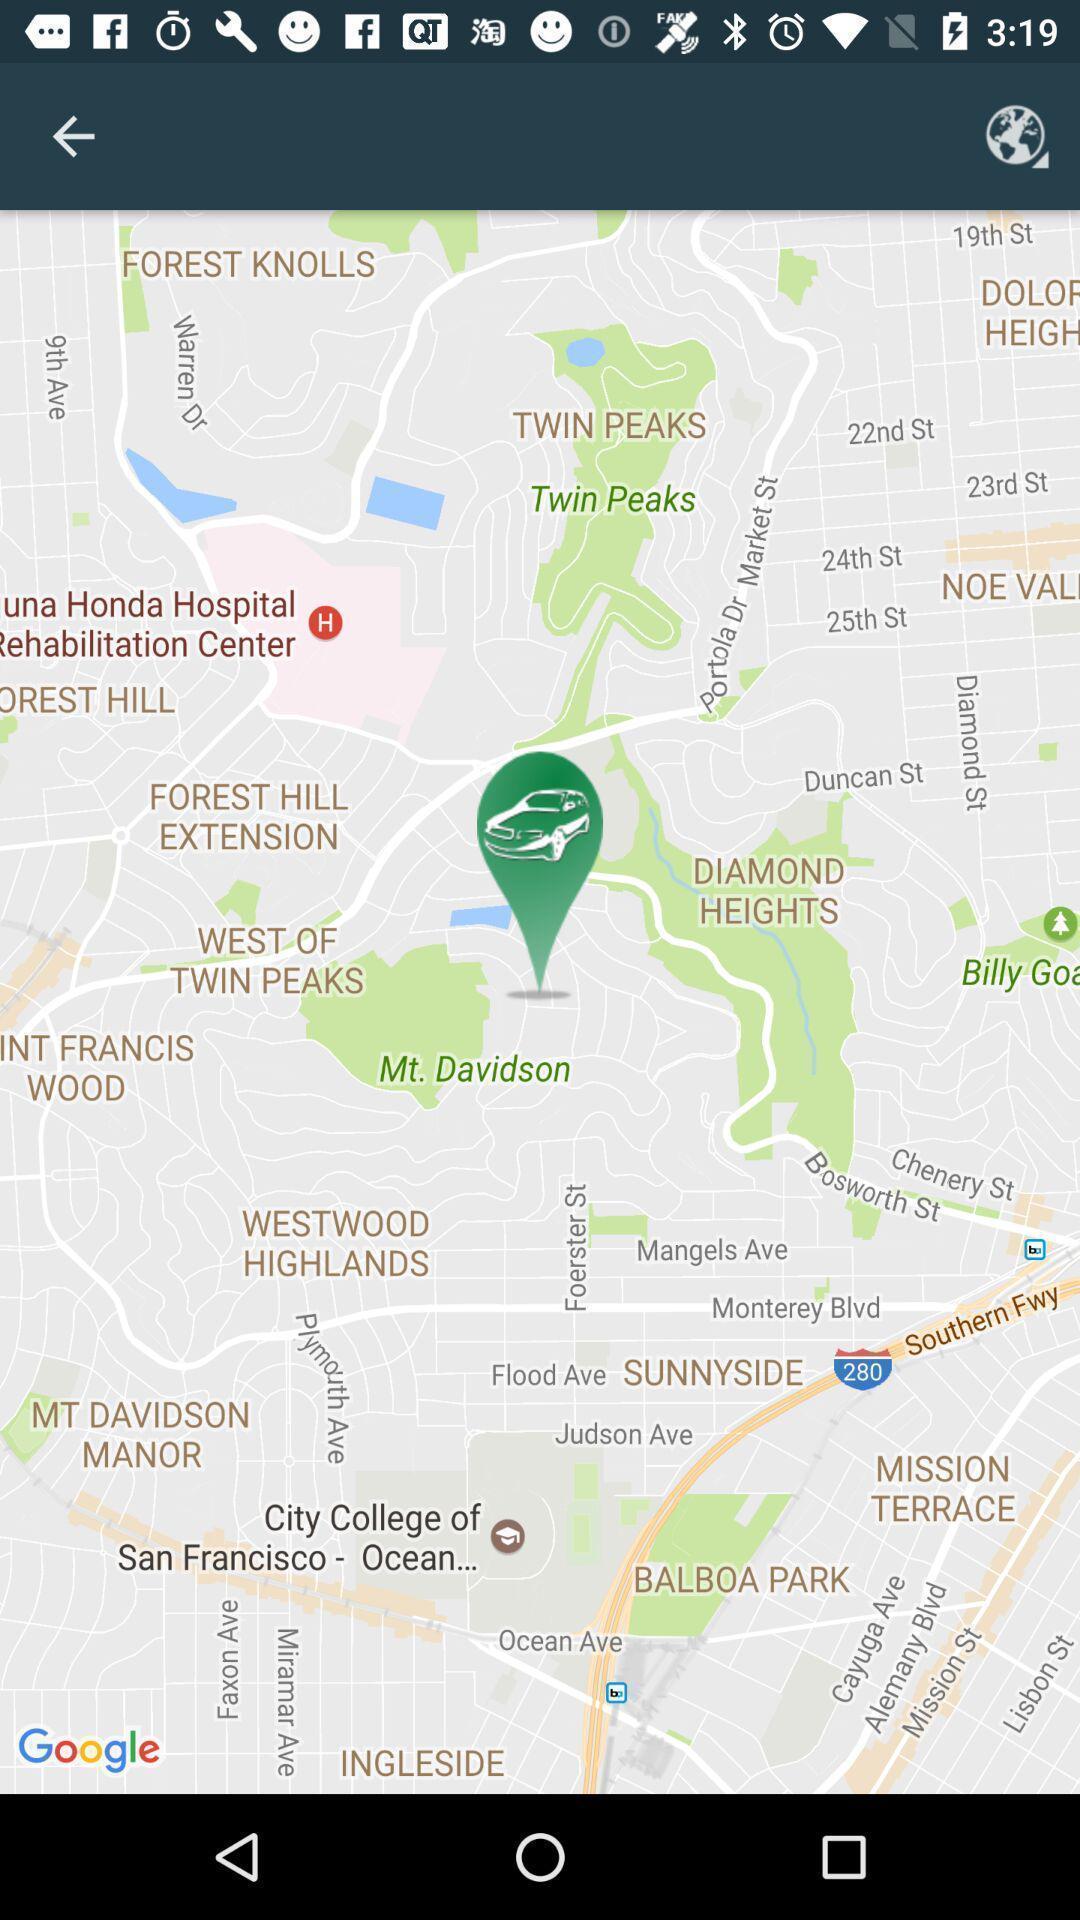Describe the visual elements of this screenshot. Page that displaying gps application. 